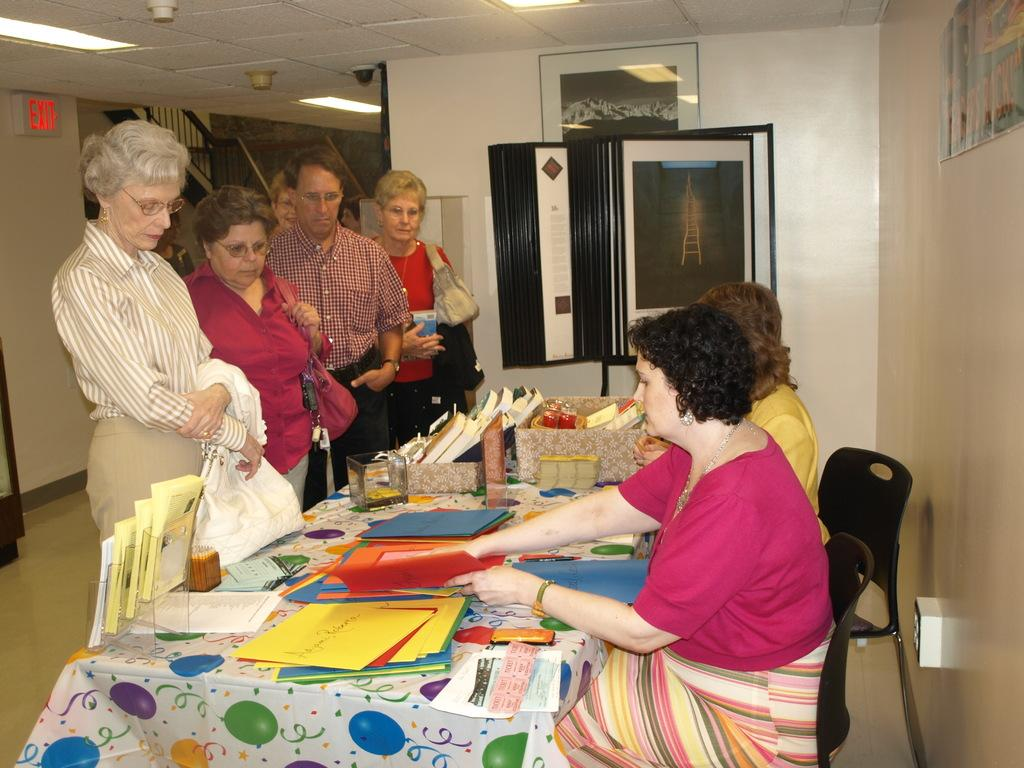What are the people in the image doing? The people are standing and watching something. What objects are on the table in the image? There are color papers on a table. What are the two women doing in the image? The two women are seated on chairs and showing the papers to people. Where is the shelf located in the image? There is no shelf present in the image. What type of reward is being given to the people in the image? There is no reward being given in the image; the people are watching something and the women are showing papers to them. 